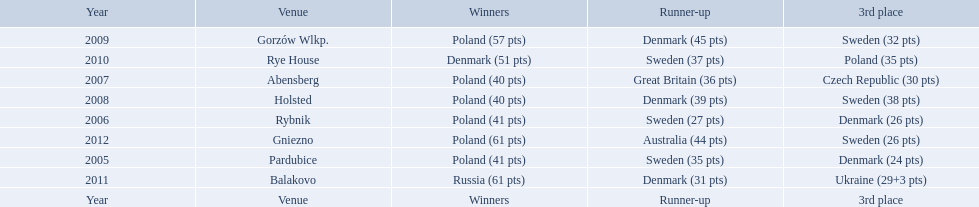Did holland win the 2010 championship? if not who did? Rye House. What did position did holland they rank? 3rd place. Parse the full table in json format. {'header': ['Year', 'Venue', 'Winners', 'Runner-up', '3rd place'], 'rows': [['2009', 'Gorzów Wlkp.', 'Poland (57 pts)', 'Denmark (45 pts)', 'Sweden (32 pts)'], ['2010', 'Rye House', 'Denmark (51 pts)', 'Sweden (37 pts)', 'Poland (35 pts)'], ['2007', 'Abensberg', 'Poland (40 pts)', 'Great Britain (36 pts)', 'Czech Republic (30 pts)'], ['2008', 'Holsted', 'Poland (40 pts)', 'Denmark (39 pts)', 'Sweden (38 pts)'], ['2006', 'Rybnik', 'Poland (41 pts)', 'Sweden (27 pts)', 'Denmark (26 pts)'], ['2012', 'Gniezno', 'Poland (61 pts)', 'Australia (44 pts)', 'Sweden (26 pts)'], ['2005', 'Pardubice', 'Poland (41 pts)', 'Sweden (35 pts)', 'Denmark (24 pts)'], ['2011', 'Balakovo', 'Russia (61 pts)', 'Denmark (31 pts)', 'Ukraine (29+3 pts)'], ['Year', 'Venue', 'Winners', 'Runner-up', '3rd place']]} After enjoying five consecutive victories at the team speedway junior world championship poland was finally unseated in what year? 2010. In that year, what teams placed first through third? Denmark (51 pts), Sweden (37 pts), Poland (35 pts). Which of those positions did poland specifically place in? 3rd place. 